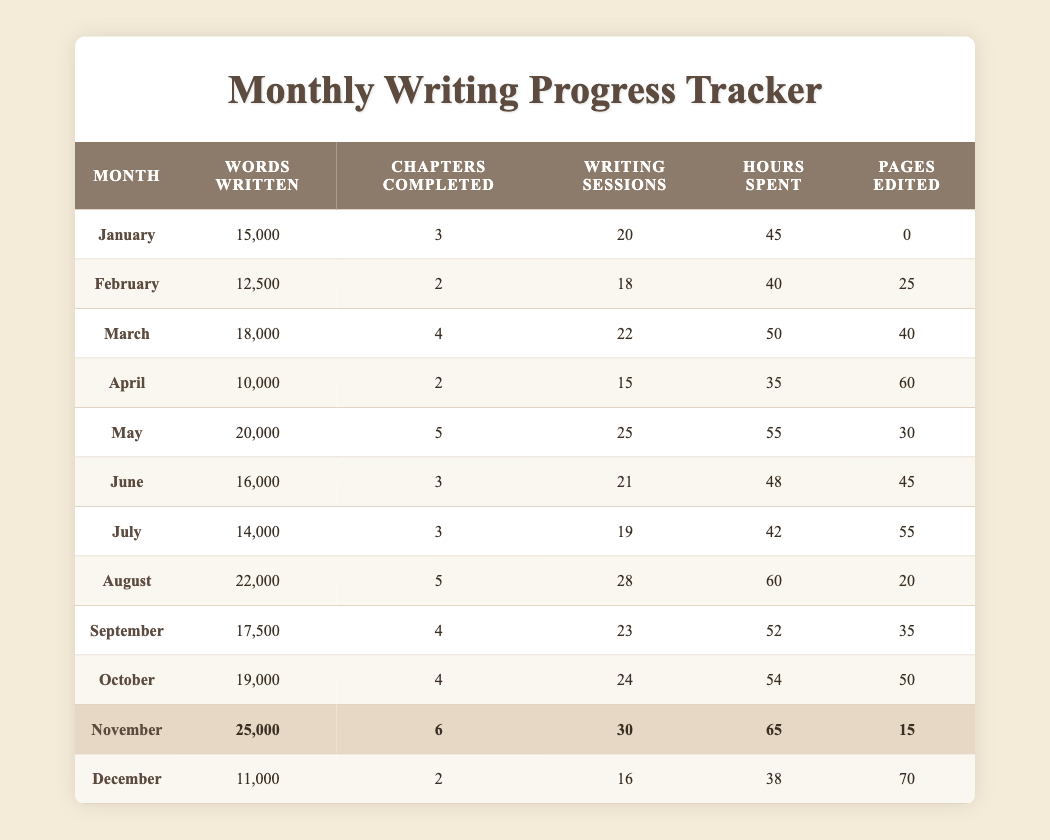What was the highest number of words written in a month? The highest number of words written in a month is found in the row with November, which shows 25,000 words.
Answer: 25000 In which month were the most chapters completed? November has the most chapters completed with 6 chapters, as seen from the respective row.
Answer: November What is the average number of writing sessions per month? The total number of writing sessions is 20 + 18 + 22 + 15 + 25 + 21 + 19 + 28 + 23 + 24 + 30 + 16 =  290. There are 12 months, so the average is 290 / 12 = 24.17, which can be rounded to 24 writing sessions per month.
Answer: 24 Did you edit more pages in December than in February? In December, 70 pages were edited, while in February only 25 pages were edited. So, more pages were edited in December compared to February.
Answer: Yes What is the difference in the total hours spent from January to March? The total hours spent in January is 45, in February is 40, and in March is 50. Adding these gives 45 + 40 + 50 = 135 hours. The difference between January and March is 50 - 45 = 5 additional hours spent in March.
Answer: 5 Which month had the lowest number of words written, and how many words were written? The month with the lowest number of words written is April with 10,000 words, as seen in the respective row.
Answer: April, 10000 How many total hours were spent on writing in the second half of the year (July to December)? The hours spent in July is 42, August is 60, September is 52, October is 54, November is 65, and December is 38. Adding these gives 42 + 60 + 52 + 54 + 65 + 38 = 317 hours.
Answer: 317 Did the months with the highest pages edited correspond to the months with the highest words written? The highest pages edited were in April with 60 and November with 15, while the highest word counts were in November, which does not correspond directly as April had less. Therefore, they do not align.
Answer: No What was the total number of chapters completed throughout the year? The total number of chapters completed is obtained by adding all chapters: 3 + 2 + 4 + 2 + 5 + 3 + 3 + 5 + 4 + 4 + 6 + 2 = 4 0 chapters total completed in the year.
Answer: 40 